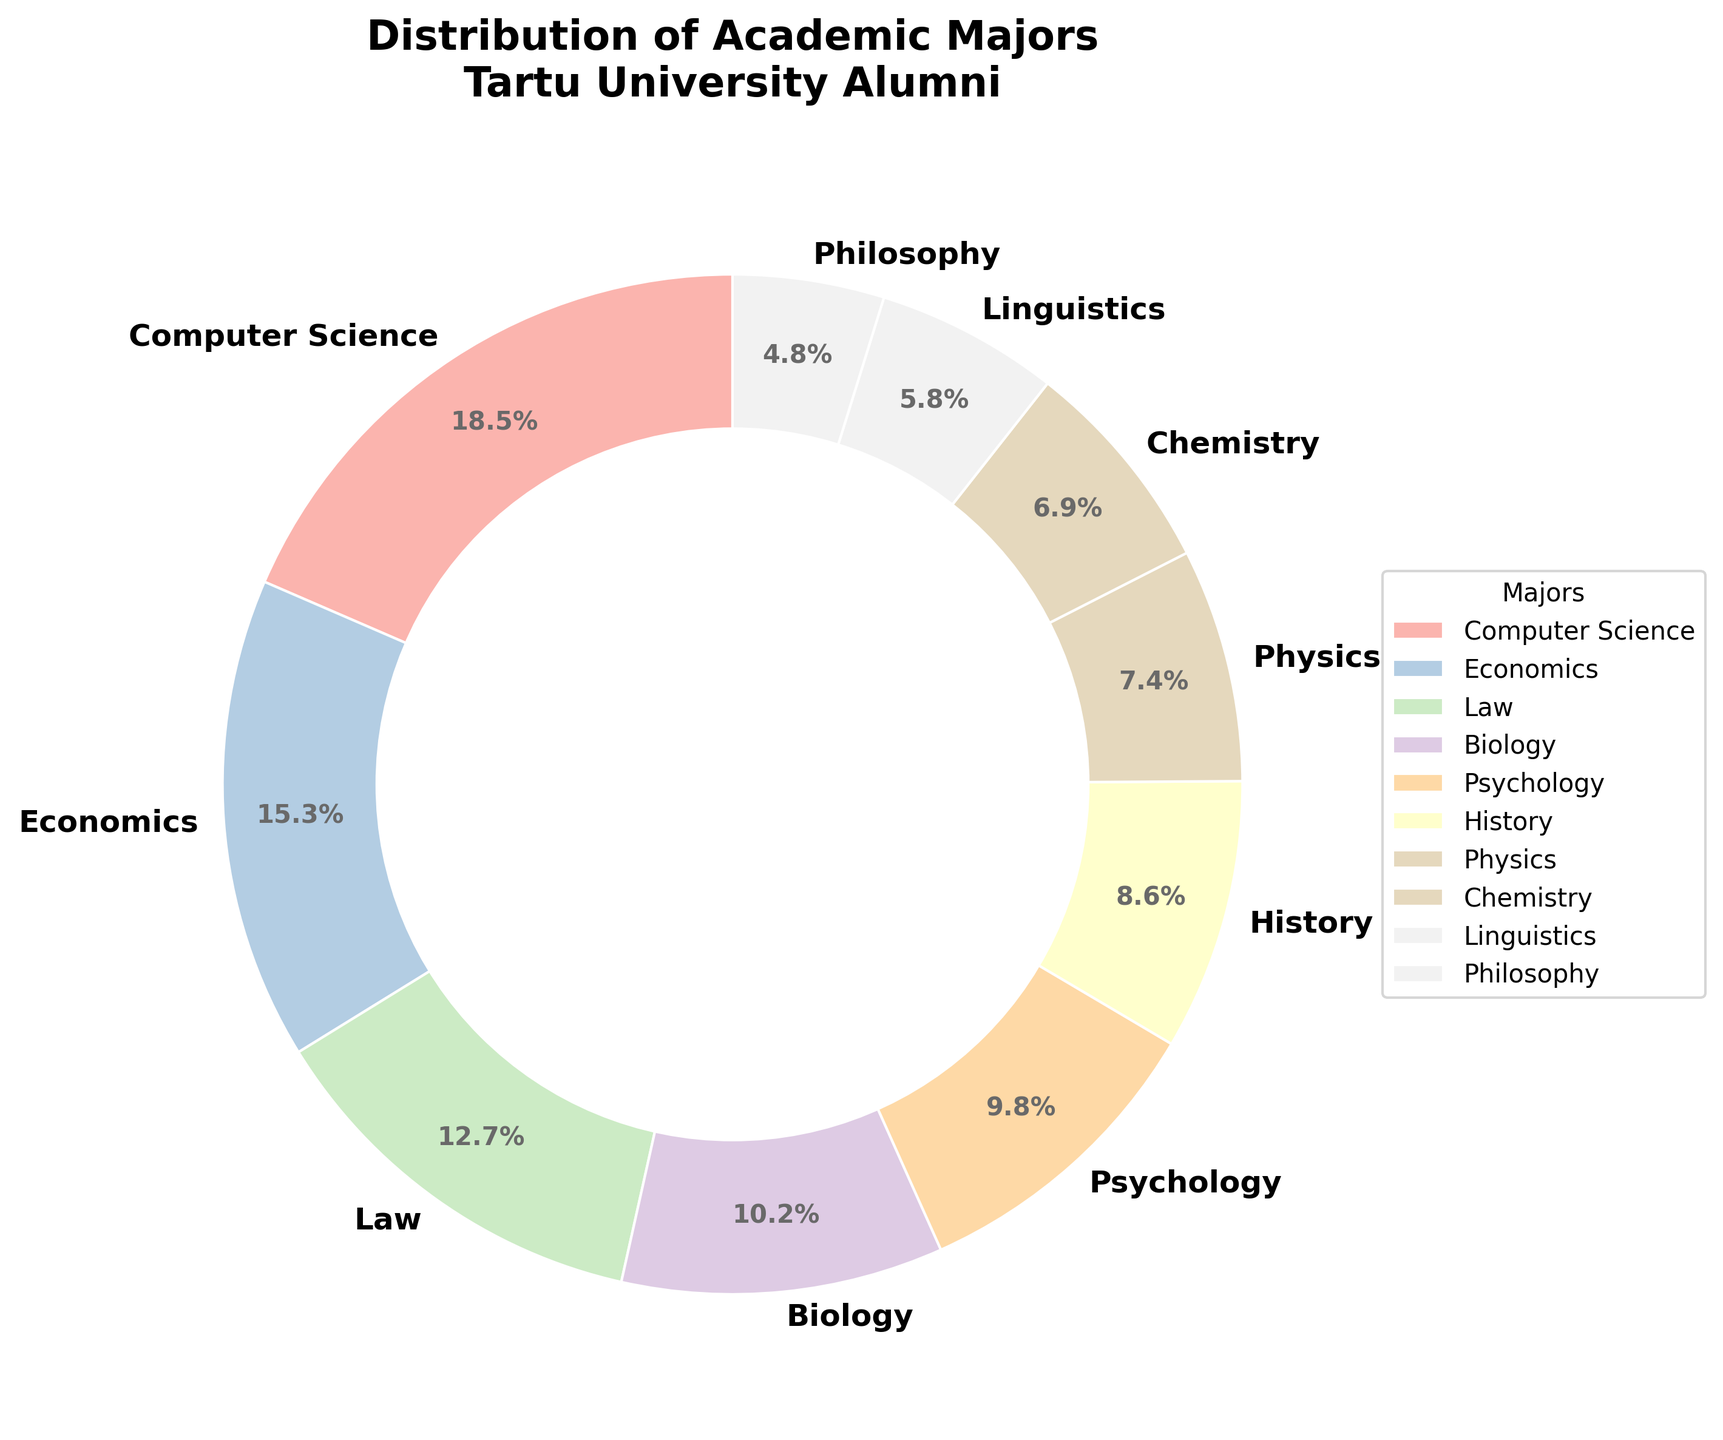what’s the most common major among Andres Toode’s cohort? To answer this, we have to look at which segment of the pie chart is the largest. The largest segment corresponds to Computer Science with 18.5%.
Answer: Computer Science Which two majors combined have the largest representation? To find this, we need to look at the two highest percentages and sum them up. Computer Science has 18.5% and Economics has 15.3%. So, 18.5% + 15.3% = 33.8%.
Answer: Computer Science and Economics What’s the difference in percentage between the Computer Science and Psychology majors? We subtract the percentage of Psychology (9.8%) from Computer Science (18.5%). 18.5% - 9.8% = 8.7%.
Answer: 8.7% Which major has a higher percentage: Chemistry or Physics? By comparing the two segments for Chemistry and Physics, we find Chemistry has 6.9% and Physics has 7.4%.
Answer: Physics How many majors have a percentage less than 10%? We count all the segments with percentages less than 10%. They are Biology (10.2%), Psychology (9.8%), History (8.6%), Physics (7.4%), Chemistry (6.9%), Linguistics (5.8%), Philosophy (4.8%). Therefore, there are 7.
Answer: 7 What is the total percentage of Biology, Chemistry, and Physics combined? We add the percentages for Biology (10.2%), Chemistry (6.9%), and Physics (7.4%). 10.2% + 6.9% + 7.4% = 24.5%.
Answer: 24.5% Which segment is represented by a green color? The specific color assignment can be verified by looking at the pie chart legend and matching the major to the "green" color segment.
Answer: (Assuming based on coding detail, not expected to have this precise knowledge) Not answerable without actual pie chart Rank the top three majors by percentage. To find the top three, we sort the percentages in descending order. The top three are Computer Science (18.5%), Economics (15.3%), and Law (12.7%).
Answer: Computer Science, Economics, Law What is the average percentage of all the majors combined? Sum all the percentages and divide by the number of majors. (18.5% + 15.3% + 12.7% + 10.2% + 9.8% + 8.6% + 7.4% + 6.9% + 5.8% + 4.8%) / 10 = 100.0% / 10 = 10%.
Answer: 10% Compare the sum of percentages of the least three represented majors to the percentage of the most represented major. Least three percentages are Philosophy (4.8%), Linguistics (5.8%), Chemistry (6.9%) with the total of 4.8% + 5.8% + 6.9% = 17.5%. Most represented: Computer Science with 18.5%. So 17.5% < 18.5%.
Answer: Less 